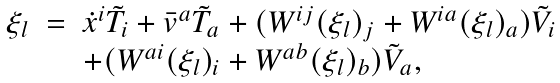Convert formula to latex. <formula><loc_0><loc_0><loc_500><loc_500>\begin{array} { r c l } \xi _ { l } & = & \dot { x } ^ { i } \tilde { T } _ { i } + \bar { v } ^ { a } \tilde { T } _ { a } + ( W ^ { i j } ( \xi _ { l } ) _ { j } + W ^ { i a } ( \xi _ { l } ) _ { a } ) \tilde { V } _ { i } \\ & & + ( W ^ { a i } ( \xi _ { l } ) _ { i } + W ^ { a b } ( \xi _ { l } ) _ { b } ) \tilde { V } _ { a } , \end{array}</formula> 